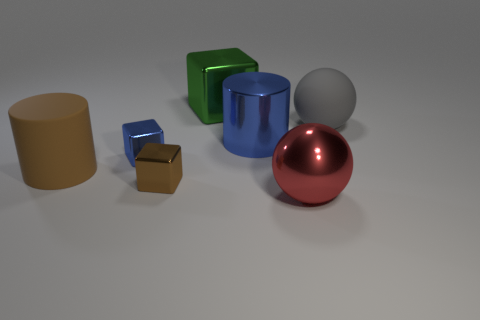Are there more tiny brown things than tiny cyan spheres?
Keep it short and to the point. Yes. There is a matte sphere that is to the right of the rubber thing that is left of the ball that is in front of the gray object; what color is it?
Offer a very short reply. Gray. There is a rubber thing that is on the left side of the large metal cylinder; is it the same color as the tiny object in front of the blue block?
Offer a terse response. Yes. There is a large rubber object that is to the right of the brown rubber cylinder; how many brown matte things are in front of it?
Make the answer very short. 1. Is there a tiny blue cylinder?
Give a very brief answer. No. How many other things are there of the same color as the large shiny cylinder?
Provide a succinct answer. 1. Is the number of yellow shiny balls less than the number of brown objects?
Your answer should be very brief. Yes. What is the shape of the tiny metallic object that is behind the brown rubber cylinder that is behind the small brown metallic block?
Your response must be concise. Cube. There is a red shiny ball; are there any large balls on the right side of it?
Make the answer very short. Yes. The other cylinder that is the same size as the metallic cylinder is what color?
Make the answer very short. Brown. 